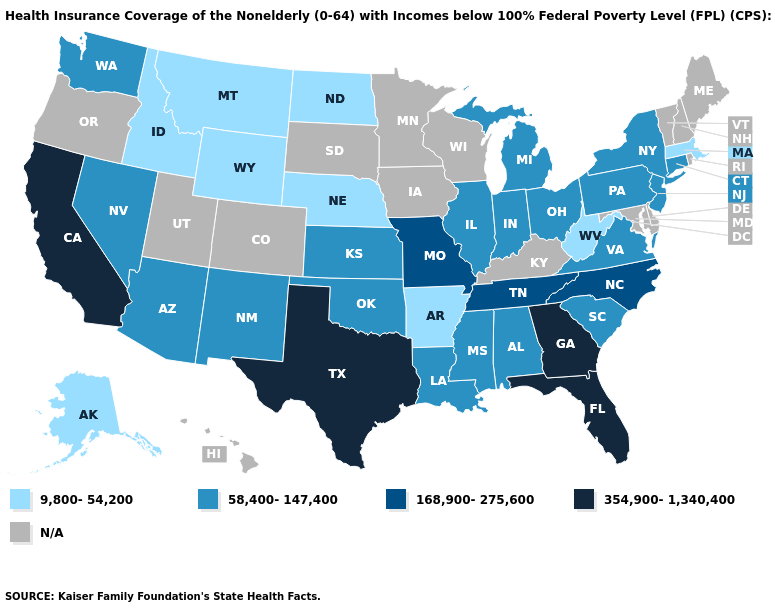Name the states that have a value in the range 168,900-275,600?
Short answer required. Missouri, North Carolina, Tennessee. Among the states that border Missouri , does Nebraska have the highest value?
Short answer required. No. What is the lowest value in the MidWest?
Keep it brief. 9,800-54,200. What is the value of Nebraska?
Be succinct. 9,800-54,200. Does California have the highest value in the USA?
Give a very brief answer. Yes. Name the states that have a value in the range 168,900-275,600?
Give a very brief answer. Missouri, North Carolina, Tennessee. Which states have the lowest value in the South?
Concise answer only. Arkansas, West Virginia. Among the states that border New Hampshire , which have the lowest value?
Keep it brief. Massachusetts. Does Massachusetts have the lowest value in the Northeast?
Keep it brief. Yes. Which states have the highest value in the USA?
Answer briefly. California, Florida, Georgia, Texas. What is the value of South Dakota?
Write a very short answer. N/A. Does Nebraska have the highest value in the MidWest?
Answer briefly. No. Which states hav the highest value in the MidWest?
Short answer required. Missouri. What is the lowest value in states that border Kentucky?
Give a very brief answer. 9,800-54,200. 